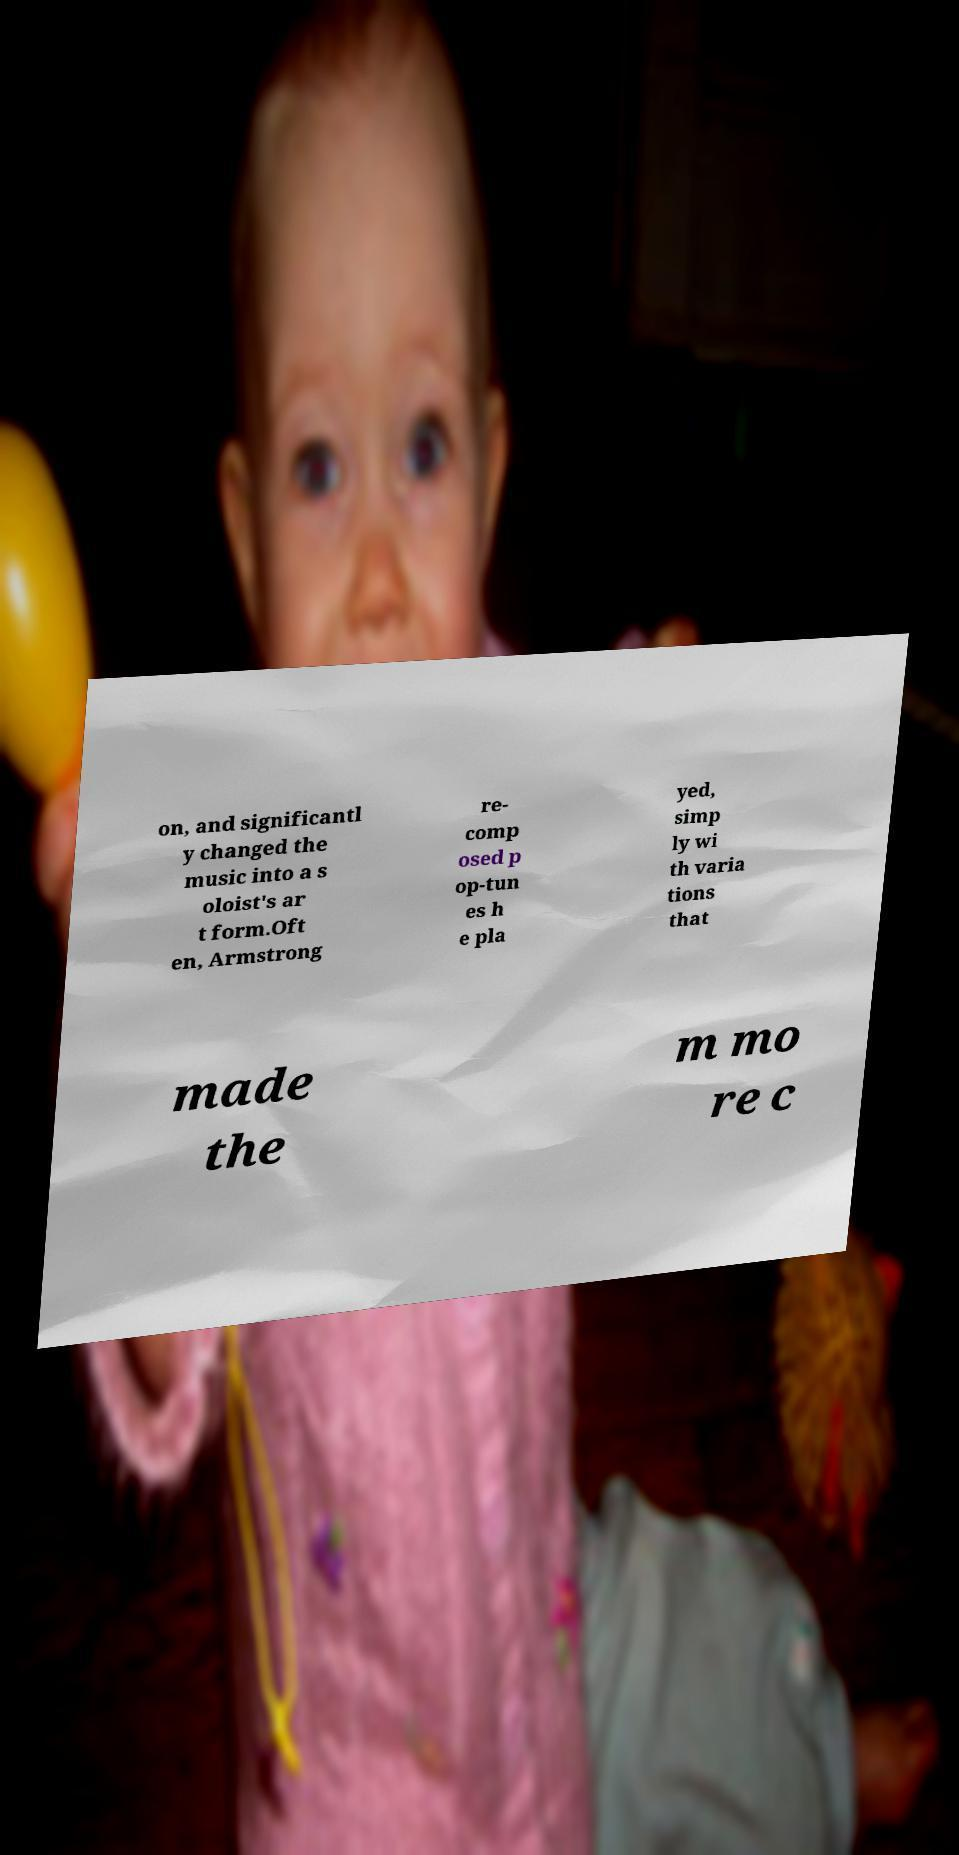Could you extract and type out the text from this image? on, and significantl y changed the music into a s oloist's ar t form.Oft en, Armstrong re- comp osed p op-tun es h e pla yed, simp ly wi th varia tions that made the m mo re c 